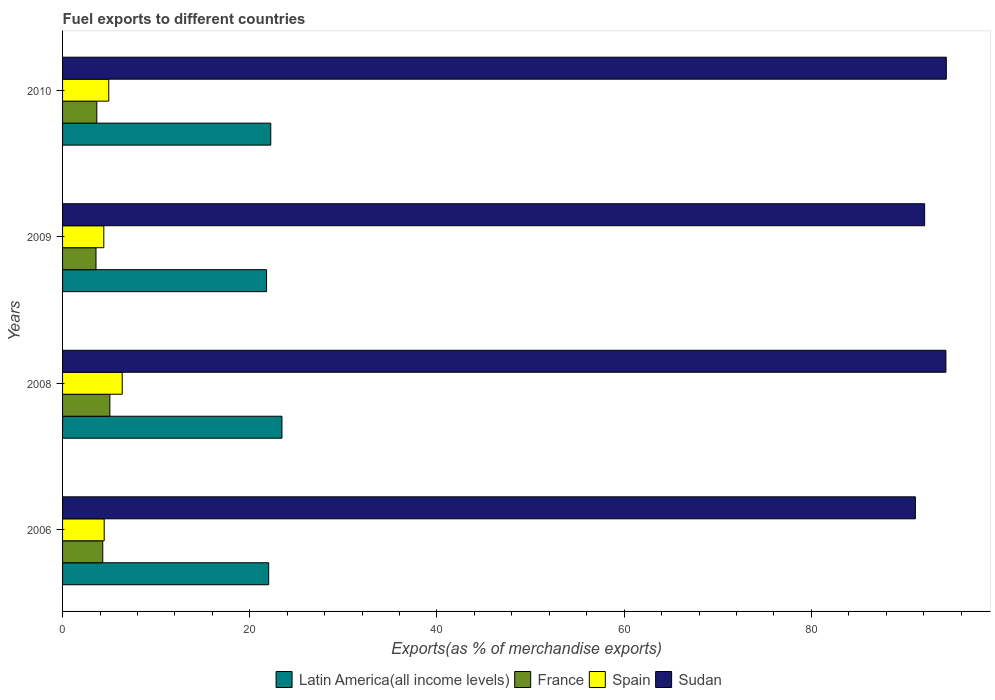Are the number of bars per tick equal to the number of legend labels?
Your response must be concise. Yes. Are the number of bars on each tick of the Y-axis equal?
Your answer should be compact. Yes. How many bars are there on the 4th tick from the top?
Keep it short and to the point. 4. What is the label of the 1st group of bars from the top?
Your response must be concise. 2010. What is the percentage of exports to different countries in Sudan in 2009?
Keep it short and to the point. 92.1. Across all years, what is the maximum percentage of exports to different countries in France?
Make the answer very short. 5.05. Across all years, what is the minimum percentage of exports to different countries in Sudan?
Your response must be concise. 91.11. In which year was the percentage of exports to different countries in Latin America(all income levels) maximum?
Ensure brevity in your answer.  2008. In which year was the percentage of exports to different countries in France minimum?
Your response must be concise. 2009. What is the total percentage of exports to different countries in Latin America(all income levels) in the graph?
Provide a succinct answer. 89.49. What is the difference between the percentage of exports to different countries in Latin America(all income levels) in 2009 and that in 2010?
Offer a very short reply. -0.45. What is the difference between the percentage of exports to different countries in Latin America(all income levels) in 2009 and the percentage of exports to different countries in Sudan in 2008?
Offer a very short reply. -72.58. What is the average percentage of exports to different countries in Sudan per year?
Give a very brief answer. 93. In the year 2009, what is the difference between the percentage of exports to different countries in Spain and percentage of exports to different countries in France?
Provide a succinct answer. 0.83. What is the ratio of the percentage of exports to different countries in Sudan in 2006 to that in 2010?
Keep it short and to the point. 0.97. Is the percentage of exports to different countries in Spain in 2009 less than that in 2010?
Your answer should be very brief. Yes. Is the difference between the percentage of exports to different countries in Spain in 2006 and 2008 greater than the difference between the percentage of exports to different countries in France in 2006 and 2008?
Keep it short and to the point. No. What is the difference between the highest and the second highest percentage of exports to different countries in France?
Offer a very short reply. 0.76. What is the difference between the highest and the lowest percentage of exports to different countries in France?
Provide a succinct answer. 1.48. In how many years, is the percentage of exports to different countries in France greater than the average percentage of exports to different countries in France taken over all years?
Your response must be concise. 2. Is the sum of the percentage of exports to different countries in Latin America(all income levels) in 2008 and 2009 greater than the maximum percentage of exports to different countries in Sudan across all years?
Offer a very short reply. No. What does the 4th bar from the top in 2009 represents?
Your answer should be compact. Latin America(all income levels). What does the 1st bar from the bottom in 2010 represents?
Provide a succinct answer. Latin America(all income levels). How many bars are there?
Give a very brief answer. 16. Are all the bars in the graph horizontal?
Your response must be concise. Yes. What is the difference between two consecutive major ticks on the X-axis?
Ensure brevity in your answer.  20. Does the graph contain any zero values?
Your answer should be compact. No. Where does the legend appear in the graph?
Your response must be concise. Bottom center. How many legend labels are there?
Your answer should be compact. 4. How are the legend labels stacked?
Keep it short and to the point. Horizontal. What is the title of the graph?
Provide a succinct answer. Fuel exports to different countries. Does "Other small states" appear as one of the legend labels in the graph?
Your response must be concise. No. What is the label or title of the X-axis?
Keep it short and to the point. Exports(as % of merchandise exports). What is the Exports(as % of merchandise exports) of Latin America(all income levels) in 2006?
Provide a short and direct response. 22.02. What is the Exports(as % of merchandise exports) in France in 2006?
Your answer should be compact. 4.29. What is the Exports(as % of merchandise exports) of Spain in 2006?
Your answer should be compact. 4.45. What is the Exports(as % of merchandise exports) of Sudan in 2006?
Your answer should be very brief. 91.11. What is the Exports(as % of merchandise exports) in Latin America(all income levels) in 2008?
Offer a very short reply. 23.44. What is the Exports(as % of merchandise exports) in France in 2008?
Ensure brevity in your answer.  5.05. What is the Exports(as % of merchandise exports) in Spain in 2008?
Offer a terse response. 6.37. What is the Exports(as % of merchandise exports) of Sudan in 2008?
Your response must be concise. 94.37. What is the Exports(as % of merchandise exports) of Latin America(all income levels) in 2009?
Ensure brevity in your answer.  21.79. What is the Exports(as % of merchandise exports) of France in 2009?
Provide a short and direct response. 3.57. What is the Exports(as % of merchandise exports) of Spain in 2009?
Offer a very short reply. 4.41. What is the Exports(as % of merchandise exports) of Sudan in 2009?
Your response must be concise. 92.1. What is the Exports(as % of merchandise exports) in Latin America(all income levels) in 2010?
Your answer should be very brief. 22.24. What is the Exports(as % of merchandise exports) in France in 2010?
Ensure brevity in your answer.  3.66. What is the Exports(as % of merchandise exports) in Spain in 2010?
Offer a terse response. 4.93. What is the Exports(as % of merchandise exports) in Sudan in 2010?
Your response must be concise. 94.41. Across all years, what is the maximum Exports(as % of merchandise exports) in Latin America(all income levels)?
Offer a very short reply. 23.44. Across all years, what is the maximum Exports(as % of merchandise exports) in France?
Make the answer very short. 5.05. Across all years, what is the maximum Exports(as % of merchandise exports) of Spain?
Offer a very short reply. 6.37. Across all years, what is the maximum Exports(as % of merchandise exports) in Sudan?
Provide a succinct answer. 94.41. Across all years, what is the minimum Exports(as % of merchandise exports) in Latin America(all income levels)?
Ensure brevity in your answer.  21.79. Across all years, what is the minimum Exports(as % of merchandise exports) in France?
Offer a terse response. 3.57. Across all years, what is the minimum Exports(as % of merchandise exports) in Spain?
Offer a very short reply. 4.41. Across all years, what is the minimum Exports(as % of merchandise exports) in Sudan?
Your answer should be very brief. 91.11. What is the total Exports(as % of merchandise exports) in Latin America(all income levels) in the graph?
Offer a very short reply. 89.49. What is the total Exports(as % of merchandise exports) of France in the graph?
Make the answer very short. 16.58. What is the total Exports(as % of merchandise exports) of Spain in the graph?
Offer a terse response. 20.16. What is the total Exports(as % of merchandise exports) of Sudan in the graph?
Your answer should be very brief. 371.99. What is the difference between the Exports(as % of merchandise exports) of Latin America(all income levels) in 2006 and that in 2008?
Your answer should be compact. -1.42. What is the difference between the Exports(as % of merchandise exports) of France in 2006 and that in 2008?
Give a very brief answer. -0.76. What is the difference between the Exports(as % of merchandise exports) in Spain in 2006 and that in 2008?
Ensure brevity in your answer.  -1.93. What is the difference between the Exports(as % of merchandise exports) in Sudan in 2006 and that in 2008?
Give a very brief answer. -3.26. What is the difference between the Exports(as % of merchandise exports) of Latin America(all income levels) in 2006 and that in 2009?
Give a very brief answer. 0.23. What is the difference between the Exports(as % of merchandise exports) of France in 2006 and that in 2009?
Your answer should be very brief. 0.72. What is the difference between the Exports(as % of merchandise exports) in Spain in 2006 and that in 2009?
Your answer should be compact. 0.04. What is the difference between the Exports(as % of merchandise exports) of Sudan in 2006 and that in 2009?
Provide a short and direct response. -0.99. What is the difference between the Exports(as % of merchandise exports) of Latin America(all income levels) in 2006 and that in 2010?
Your answer should be compact. -0.22. What is the difference between the Exports(as % of merchandise exports) in France in 2006 and that in 2010?
Keep it short and to the point. 0.64. What is the difference between the Exports(as % of merchandise exports) in Spain in 2006 and that in 2010?
Give a very brief answer. -0.49. What is the difference between the Exports(as % of merchandise exports) of Sudan in 2006 and that in 2010?
Ensure brevity in your answer.  -3.3. What is the difference between the Exports(as % of merchandise exports) of Latin America(all income levels) in 2008 and that in 2009?
Your answer should be compact. 1.65. What is the difference between the Exports(as % of merchandise exports) of France in 2008 and that in 2009?
Your answer should be compact. 1.48. What is the difference between the Exports(as % of merchandise exports) of Spain in 2008 and that in 2009?
Your answer should be very brief. 1.97. What is the difference between the Exports(as % of merchandise exports) in Sudan in 2008 and that in 2009?
Offer a very short reply. 2.27. What is the difference between the Exports(as % of merchandise exports) in Latin America(all income levels) in 2008 and that in 2010?
Provide a succinct answer. 1.2. What is the difference between the Exports(as % of merchandise exports) of France in 2008 and that in 2010?
Your answer should be very brief. 1.4. What is the difference between the Exports(as % of merchandise exports) of Spain in 2008 and that in 2010?
Offer a very short reply. 1.44. What is the difference between the Exports(as % of merchandise exports) of Sudan in 2008 and that in 2010?
Provide a succinct answer. -0.04. What is the difference between the Exports(as % of merchandise exports) in Latin America(all income levels) in 2009 and that in 2010?
Keep it short and to the point. -0.45. What is the difference between the Exports(as % of merchandise exports) in France in 2009 and that in 2010?
Your response must be concise. -0.09. What is the difference between the Exports(as % of merchandise exports) of Spain in 2009 and that in 2010?
Provide a succinct answer. -0.53. What is the difference between the Exports(as % of merchandise exports) of Sudan in 2009 and that in 2010?
Give a very brief answer. -2.31. What is the difference between the Exports(as % of merchandise exports) in Latin America(all income levels) in 2006 and the Exports(as % of merchandise exports) in France in 2008?
Provide a short and direct response. 16.96. What is the difference between the Exports(as % of merchandise exports) in Latin America(all income levels) in 2006 and the Exports(as % of merchandise exports) in Spain in 2008?
Give a very brief answer. 15.65. What is the difference between the Exports(as % of merchandise exports) of Latin America(all income levels) in 2006 and the Exports(as % of merchandise exports) of Sudan in 2008?
Offer a very short reply. -72.35. What is the difference between the Exports(as % of merchandise exports) in France in 2006 and the Exports(as % of merchandise exports) in Spain in 2008?
Keep it short and to the point. -2.08. What is the difference between the Exports(as % of merchandise exports) in France in 2006 and the Exports(as % of merchandise exports) in Sudan in 2008?
Provide a short and direct response. -90.08. What is the difference between the Exports(as % of merchandise exports) in Spain in 2006 and the Exports(as % of merchandise exports) in Sudan in 2008?
Provide a succinct answer. -89.92. What is the difference between the Exports(as % of merchandise exports) in Latin America(all income levels) in 2006 and the Exports(as % of merchandise exports) in France in 2009?
Keep it short and to the point. 18.45. What is the difference between the Exports(as % of merchandise exports) in Latin America(all income levels) in 2006 and the Exports(as % of merchandise exports) in Spain in 2009?
Ensure brevity in your answer.  17.61. What is the difference between the Exports(as % of merchandise exports) in Latin America(all income levels) in 2006 and the Exports(as % of merchandise exports) in Sudan in 2009?
Make the answer very short. -70.08. What is the difference between the Exports(as % of merchandise exports) of France in 2006 and the Exports(as % of merchandise exports) of Spain in 2009?
Your answer should be compact. -0.11. What is the difference between the Exports(as % of merchandise exports) of France in 2006 and the Exports(as % of merchandise exports) of Sudan in 2009?
Your answer should be very brief. -87.8. What is the difference between the Exports(as % of merchandise exports) of Spain in 2006 and the Exports(as % of merchandise exports) of Sudan in 2009?
Your answer should be very brief. -87.65. What is the difference between the Exports(as % of merchandise exports) in Latin America(all income levels) in 2006 and the Exports(as % of merchandise exports) in France in 2010?
Offer a terse response. 18.36. What is the difference between the Exports(as % of merchandise exports) of Latin America(all income levels) in 2006 and the Exports(as % of merchandise exports) of Spain in 2010?
Make the answer very short. 17.08. What is the difference between the Exports(as % of merchandise exports) in Latin America(all income levels) in 2006 and the Exports(as % of merchandise exports) in Sudan in 2010?
Your response must be concise. -72.39. What is the difference between the Exports(as % of merchandise exports) of France in 2006 and the Exports(as % of merchandise exports) of Spain in 2010?
Provide a succinct answer. -0.64. What is the difference between the Exports(as % of merchandise exports) in France in 2006 and the Exports(as % of merchandise exports) in Sudan in 2010?
Make the answer very short. -90.12. What is the difference between the Exports(as % of merchandise exports) in Spain in 2006 and the Exports(as % of merchandise exports) in Sudan in 2010?
Ensure brevity in your answer.  -89.96. What is the difference between the Exports(as % of merchandise exports) in Latin America(all income levels) in 2008 and the Exports(as % of merchandise exports) in France in 2009?
Your answer should be very brief. 19.87. What is the difference between the Exports(as % of merchandise exports) of Latin America(all income levels) in 2008 and the Exports(as % of merchandise exports) of Spain in 2009?
Offer a terse response. 19.03. What is the difference between the Exports(as % of merchandise exports) in Latin America(all income levels) in 2008 and the Exports(as % of merchandise exports) in Sudan in 2009?
Your answer should be compact. -68.66. What is the difference between the Exports(as % of merchandise exports) of France in 2008 and the Exports(as % of merchandise exports) of Spain in 2009?
Your answer should be compact. 0.65. What is the difference between the Exports(as % of merchandise exports) in France in 2008 and the Exports(as % of merchandise exports) in Sudan in 2009?
Keep it short and to the point. -87.04. What is the difference between the Exports(as % of merchandise exports) in Spain in 2008 and the Exports(as % of merchandise exports) in Sudan in 2009?
Keep it short and to the point. -85.72. What is the difference between the Exports(as % of merchandise exports) in Latin America(all income levels) in 2008 and the Exports(as % of merchandise exports) in France in 2010?
Provide a succinct answer. 19.78. What is the difference between the Exports(as % of merchandise exports) of Latin America(all income levels) in 2008 and the Exports(as % of merchandise exports) of Spain in 2010?
Your answer should be compact. 18.5. What is the difference between the Exports(as % of merchandise exports) of Latin America(all income levels) in 2008 and the Exports(as % of merchandise exports) of Sudan in 2010?
Keep it short and to the point. -70.97. What is the difference between the Exports(as % of merchandise exports) in France in 2008 and the Exports(as % of merchandise exports) in Spain in 2010?
Your answer should be very brief. 0.12. What is the difference between the Exports(as % of merchandise exports) of France in 2008 and the Exports(as % of merchandise exports) of Sudan in 2010?
Your answer should be very brief. -89.36. What is the difference between the Exports(as % of merchandise exports) of Spain in 2008 and the Exports(as % of merchandise exports) of Sudan in 2010?
Ensure brevity in your answer.  -88.04. What is the difference between the Exports(as % of merchandise exports) in Latin America(all income levels) in 2009 and the Exports(as % of merchandise exports) in France in 2010?
Provide a succinct answer. 18.13. What is the difference between the Exports(as % of merchandise exports) in Latin America(all income levels) in 2009 and the Exports(as % of merchandise exports) in Spain in 2010?
Keep it short and to the point. 16.86. What is the difference between the Exports(as % of merchandise exports) in Latin America(all income levels) in 2009 and the Exports(as % of merchandise exports) in Sudan in 2010?
Offer a terse response. -72.62. What is the difference between the Exports(as % of merchandise exports) of France in 2009 and the Exports(as % of merchandise exports) of Spain in 2010?
Make the answer very short. -1.36. What is the difference between the Exports(as % of merchandise exports) of France in 2009 and the Exports(as % of merchandise exports) of Sudan in 2010?
Make the answer very short. -90.84. What is the difference between the Exports(as % of merchandise exports) in Spain in 2009 and the Exports(as % of merchandise exports) in Sudan in 2010?
Your answer should be very brief. -90.01. What is the average Exports(as % of merchandise exports) of Latin America(all income levels) per year?
Provide a succinct answer. 22.37. What is the average Exports(as % of merchandise exports) of France per year?
Your answer should be compact. 4.14. What is the average Exports(as % of merchandise exports) of Spain per year?
Your response must be concise. 5.04. What is the average Exports(as % of merchandise exports) of Sudan per year?
Ensure brevity in your answer.  93. In the year 2006, what is the difference between the Exports(as % of merchandise exports) of Latin America(all income levels) and Exports(as % of merchandise exports) of France?
Your answer should be very brief. 17.72. In the year 2006, what is the difference between the Exports(as % of merchandise exports) in Latin America(all income levels) and Exports(as % of merchandise exports) in Spain?
Make the answer very short. 17.57. In the year 2006, what is the difference between the Exports(as % of merchandise exports) of Latin America(all income levels) and Exports(as % of merchandise exports) of Sudan?
Give a very brief answer. -69.09. In the year 2006, what is the difference between the Exports(as % of merchandise exports) in France and Exports(as % of merchandise exports) in Spain?
Keep it short and to the point. -0.15. In the year 2006, what is the difference between the Exports(as % of merchandise exports) of France and Exports(as % of merchandise exports) of Sudan?
Your response must be concise. -86.82. In the year 2006, what is the difference between the Exports(as % of merchandise exports) of Spain and Exports(as % of merchandise exports) of Sudan?
Keep it short and to the point. -86.66. In the year 2008, what is the difference between the Exports(as % of merchandise exports) in Latin America(all income levels) and Exports(as % of merchandise exports) in France?
Offer a very short reply. 18.38. In the year 2008, what is the difference between the Exports(as % of merchandise exports) of Latin America(all income levels) and Exports(as % of merchandise exports) of Spain?
Your response must be concise. 17.07. In the year 2008, what is the difference between the Exports(as % of merchandise exports) in Latin America(all income levels) and Exports(as % of merchandise exports) in Sudan?
Make the answer very short. -70.93. In the year 2008, what is the difference between the Exports(as % of merchandise exports) in France and Exports(as % of merchandise exports) in Spain?
Provide a succinct answer. -1.32. In the year 2008, what is the difference between the Exports(as % of merchandise exports) of France and Exports(as % of merchandise exports) of Sudan?
Ensure brevity in your answer.  -89.32. In the year 2008, what is the difference between the Exports(as % of merchandise exports) in Spain and Exports(as % of merchandise exports) in Sudan?
Make the answer very short. -88. In the year 2009, what is the difference between the Exports(as % of merchandise exports) in Latin America(all income levels) and Exports(as % of merchandise exports) in France?
Your response must be concise. 18.22. In the year 2009, what is the difference between the Exports(as % of merchandise exports) in Latin America(all income levels) and Exports(as % of merchandise exports) in Spain?
Give a very brief answer. 17.39. In the year 2009, what is the difference between the Exports(as % of merchandise exports) of Latin America(all income levels) and Exports(as % of merchandise exports) of Sudan?
Provide a short and direct response. -70.3. In the year 2009, what is the difference between the Exports(as % of merchandise exports) of France and Exports(as % of merchandise exports) of Spain?
Provide a succinct answer. -0.83. In the year 2009, what is the difference between the Exports(as % of merchandise exports) in France and Exports(as % of merchandise exports) in Sudan?
Provide a short and direct response. -88.53. In the year 2009, what is the difference between the Exports(as % of merchandise exports) in Spain and Exports(as % of merchandise exports) in Sudan?
Offer a terse response. -87.69. In the year 2010, what is the difference between the Exports(as % of merchandise exports) in Latin America(all income levels) and Exports(as % of merchandise exports) in France?
Provide a succinct answer. 18.58. In the year 2010, what is the difference between the Exports(as % of merchandise exports) in Latin America(all income levels) and Exports(as % of merchandise exports) in Spain?
Make the answer very short. 17.31. In the year 2010, what is the difference between the Exports(as % of merchandise exports) in Latin America(all income levels) and Exports(as % of merchandise exports) in Sudan?
Make the answer very short. -72.17. In the year 2010, what is the difference between the Exports(as % of merchandise exports) in France and Exports(as % of merchandise exports) in Spain?
Your response must be concise. -1.28. In the year 2010, what is the difference between the Exports(as % of merchandise exports) of France and Exports(as % of merchandise exports) of Sudan?
Offer a very short reply. -90.75. In the year 2010, what is the difference between the Exports(as % of merchandise exports) of Spain and Exports(as % of merchandise exports) of Sudan?
Keep it short and to the point. -89.48. What is the ratio of the Exports(as % of merchandise exports) in Latin America(all income levels) in 2006 to that in 2008?
Provide a short and direct response. 0.94. What is the ratio of the Exports(as % of merchandise exports) in France in 2006 to that in 2008?
Provide a short and direct response. 0.85. What is the ratio of the Exports(as % of merchandise exports) of Spain in 2006 to that in 2008?
Provide a short and direct response. 0.7. What is the ratio of the Exports(as % of merchandise exports) in Sudan in 2006 to that in 2008?
Offer a terse response. 0.97. What is the ratio of the Exports(as % of merchandise exports) in Latin America(all income levels) in 2006 to that in 2009?
Give a very brief answer. 1.01. What is the ratio of the Exports(as % of merchandise exports) of France in 2006 to that in 2009?
Your answer should be very brief. 1.2. What is the ratio of the Exports(as % of merchandise exports) in Spain in 2006 to that in 2009?
Your answer should be very brief. 1.01. What is the ratio of the Exports(as % of merchandise exports) of Sudan in 2006 to that in 2009?
Your answer should be very brief. 0.99. What is the ratio of the Exports(as % of merchandise exports) in France in 2006 to that in 2010?
Make the answer very short. 1.17. What is the ratio of the Exports(as % of merchandise exports) of Spain in 2006 to that in 2010?
Make the answer very short. 0.9. What is the ratio of the Exports(as % of merchandise exports) in Latin America(all income levels) in 2008 to that in 2009?
Give a very brief answer. 1.08. What is the ratio of the Exports(as % of merchandise exports) of France in 2008 to that in 2009?
Ensure brevity in your answer.  1.42. What is the ratio of the Exports(as % of merchandise exports) in Spain in 2008 to that in 2009?
Your response must be concise. 1.45. What is the ratio of the Exports(as % of merchandise exports) in Sudan in 2008 to that in 2009?
Your answer should be compact. 1.02. What is the ratio of the Exports(as % of merchandise exports) in Latin America(all income levels) in 2008 to that in 2010?
Keep it short and to the point. 1.05. What is the ratio of the Exports(as % of merchandise exports) in France in 2008 to that in 2010?
Provide a succinct answer. 1.38. What is the ratio of the Exports(as % of merchandise exports) of Spain in 2008 to that in 2010?
Provide a succinct answer. 1.29. What is the ratio of the Exports(as % of merchandise exports) of Latin America(all income levels) in 2009 to that in 2010?
Offer a very short reply. 0.98. What is the ratio of the Exports(as % of merchandise exports) in France in 2009 to that in 2010?
Offer a very short reply. 0.98. What is the ratio of the Exports(as % of merchandise exports) of Spain in 2009 to that in 2010?
Provide a short and direct response. 0.89. What is the ratio of the Exports(as % of merchandise exports) in Sudan in 2009 to that in 2010?
Offer a very short reply. 0.98. What is the difference between the highest and the second highest Exports(as % of merchandise exports) in Latin America(all income levels)?
Give a very brief answer. 1.2. What is the difference between the highest and the second highest Exports(as % of merchandise exports) of France?
Your response must be concise. 0.76. What is the difference between the highest and the second highest Exports(as % of merchandise exports) in Spain?
Offer a very short reply. 1.44. What is the difference between the highest and the second highest Exports(as % of merchandise exports) of Sudan?
Your answer should be compact. 0.04. What is the difference between the highest and the lowest Exports(as % of merchandise exports) of Latin America(all income levels)?
Ensure brevity in your answer.  1.65. What is the difference between the highest and the lowest Exports(as % of merchandise exports) of France?
Make the answer very short. 1.48. What is the difference between the highest and the lowest Exports(as % of merchandise exports) in Spain?
Offer a terse response. 1.97. What is the difference between the highest and the lowest Exports(as % of merchandise exports) of Sudan?
Give a very brief answer. 3.3. 